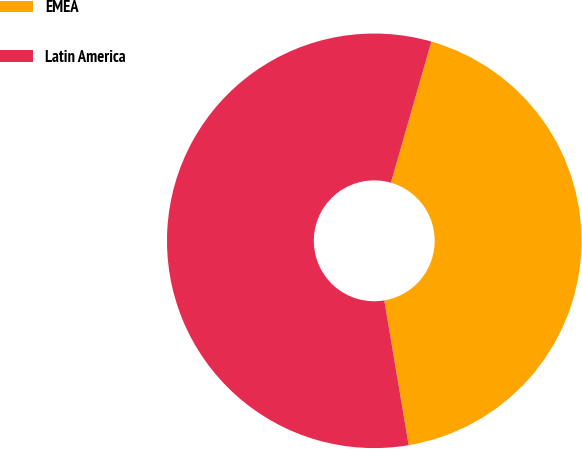Convert chart. <chart><loc_0><loc_0><loc_500><loc_500><pie_chart><fcel>EMEA<fcel>Latin America<nl><fcel>42.9%<fcel>57.1%<nl></chart> 